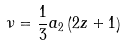<formula> <loc_0><loc_0><loc_500><loc_500>\nu = \frac { 1 } { 3 } a _ { 2 } \left ( 2 z + 1 \right )</formula> 